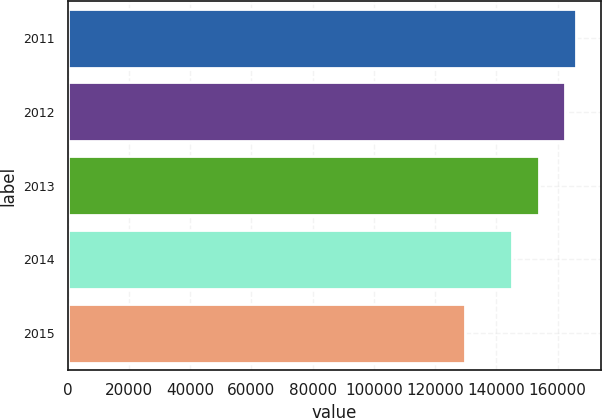Convert chart. <chart><loc_0><loc_0><loc_500><loc_500><bar_chart><fcel>2011<fcel>2012<fcel>2013<fcel>2014<fcel>2015<nl><fcel>165933<fcel>162470<fcel>154017<fcel>145045<fcel>129590<nl></chart> 